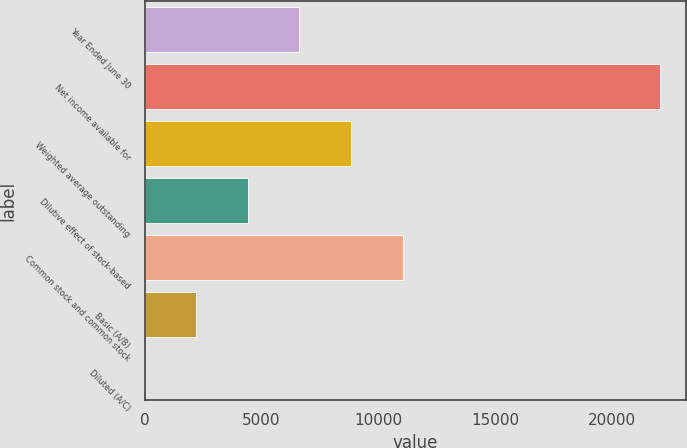Convert chart to OTSL. <chart><loc_0><loc_0><loc_500><loc_500><bar_chart><fcel>Year Ended June 30<fcel>Net income available for<fcel>Weighted average outstanding<fcel>Dilutive effect of stock-based<fcel>Common stock and common stock<fcel>Basic (A/B)<fcel>Diluted (A/C)<nl><fcel>6624.05<fcel>22074<fcel>8831.19<fcel>4416.91<fcel>11038.3<fcel>2209.77<fcel>2.63<nl></chart> 